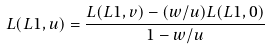<formula> <loc_0><loc_0><loc_500><loc_500>L ( L 1 , u ) = \frac { L ( L 1 , v ) - ( w / u ) L ( L 1 , 0 ) } { 1 - w / u }</formula> 